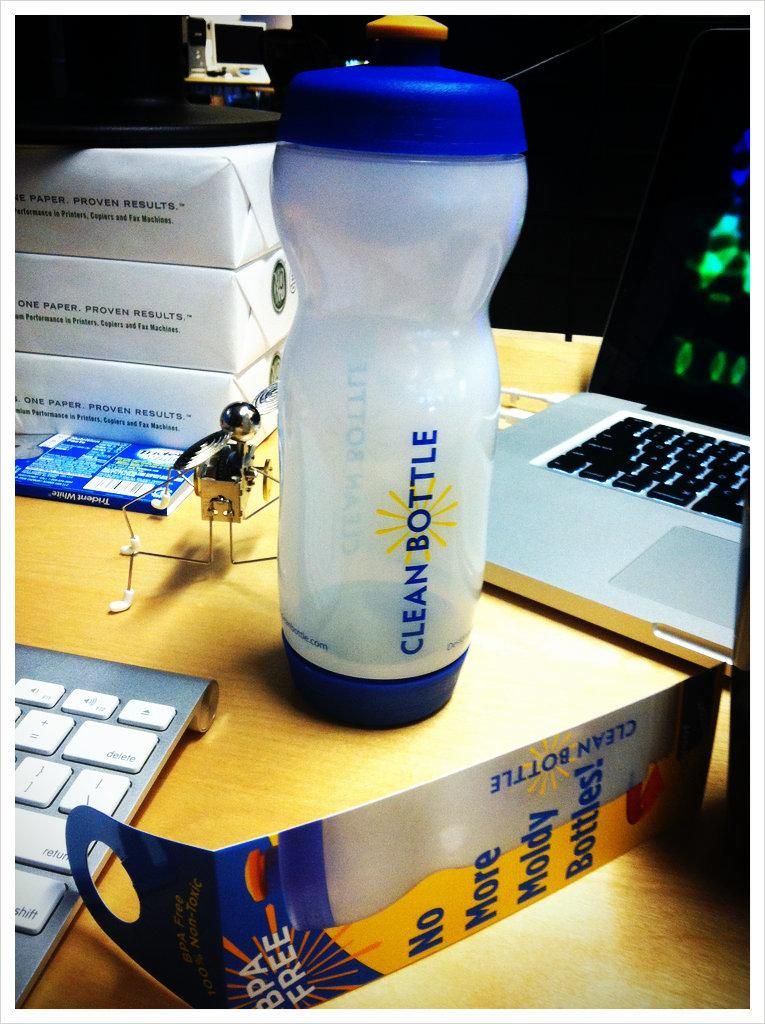<image>
Render a clear and concise summary of the photo. Clean Bottle water bottle next to an open laptop. 